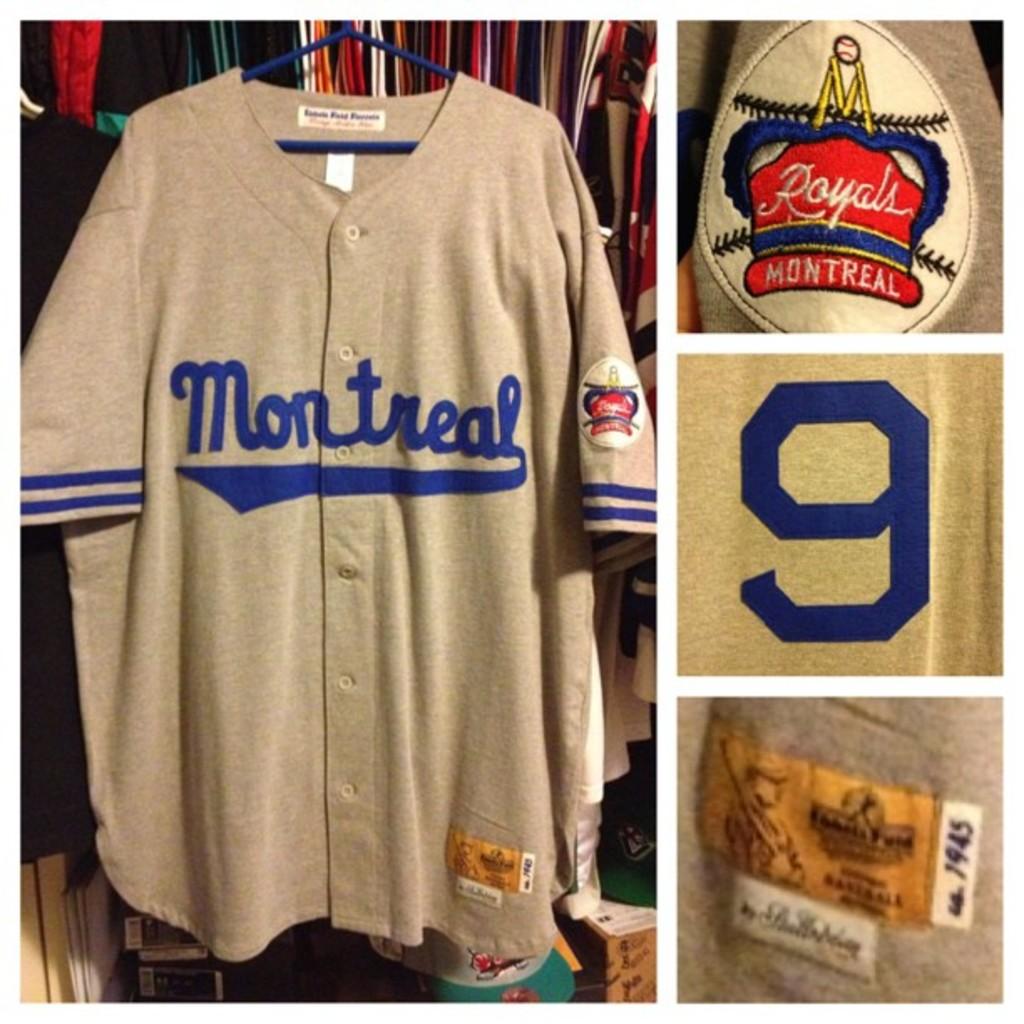What city name is on the front of the grey uniform?
Make the answer very short. Montreal. What is the number shown in the middle on the right?
Your response must be concise. 9. 